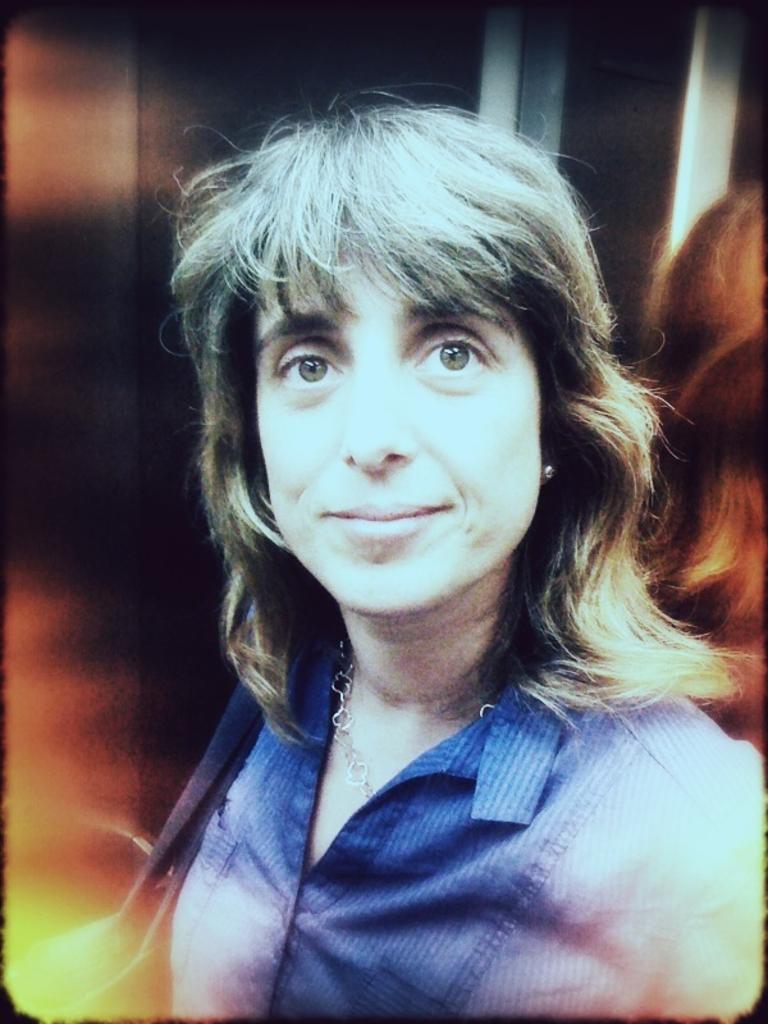How would you summarize this image in a sentence or two? In this image I can see the person with the dress and there is a blurred background. 